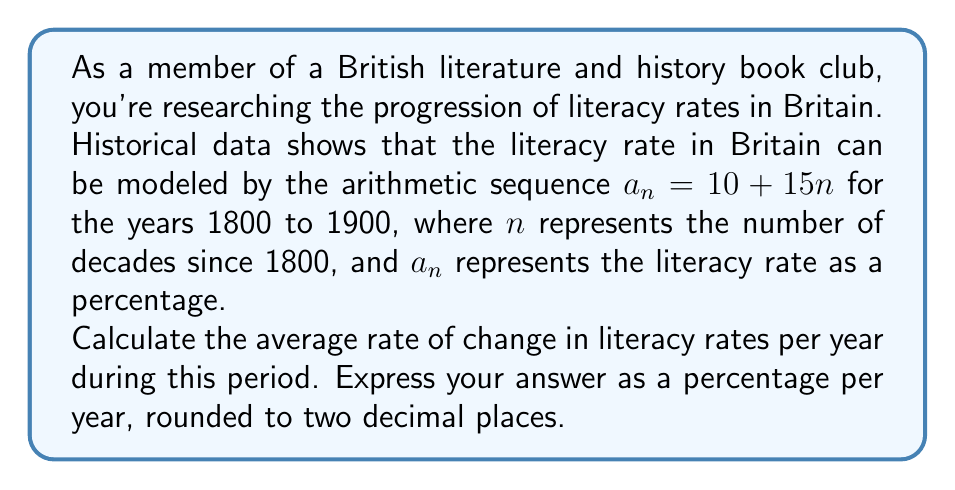Help me with this question. To solve this problem, let's follow these steps:

1) First, we need to understand what the sequence represents:
   $a_n = 10 + 15n$, where $n$ is the number of decades since 1800

2) We want to find the total change in literacy rate from 1800 to 1900:
   - In 1800, $n = 0$, so $a_0 = 10 + 15(0) = 10\%$
   - In 1900, $n = 10$, so $a_{10} = 10 + 15(10) = 160\%$

3) The total change in literacy rate is:
   $160\% - 10\% = 150\%$

4) This change occurred over 100 years (1800 to 1900)

5) To find the average rate of change per year, we divide the total change by the number of years:

   $$\text{Average rate of change} = \frac{\text{Total change}}{\text{Number of years}} = \frac{150\%}{100} = 1.5\% \text{ per year}$$

Therefore, the average rate of change in literacy rates was 1.5% per year from 1800 to 1900.
Answer: 1.5% per year 